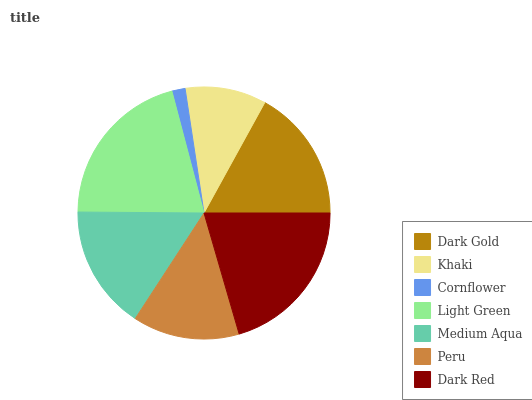Is Cornflower the minimum?
Answer yes or no. Yes. Is Light Green the maximum?
Answer yes or no. Yes. Is Khaki the minimum?
Answer yes or no. No. Is Khaki the maximum?
Answer yes or no. No. Is Dark Gold greater than Khaki?
Answer yes or no. Yes. Is Khaki less than Dark Gold?
Answer yes or no. Yes. Is Khaki greater than Dark Gold?
Answer yes or no. No. Is Dark Gold less than Khaki?
Answer yes or no. No. Is Medium Aqua the high median?
Answer yes or no. Yes. Is Medium Aqua the low median?
Answer yes or no. Yes. Is Light Green the high median?
Answer yes or no. No. Is Dark Gold the low median?
Answer yes or no. No. 